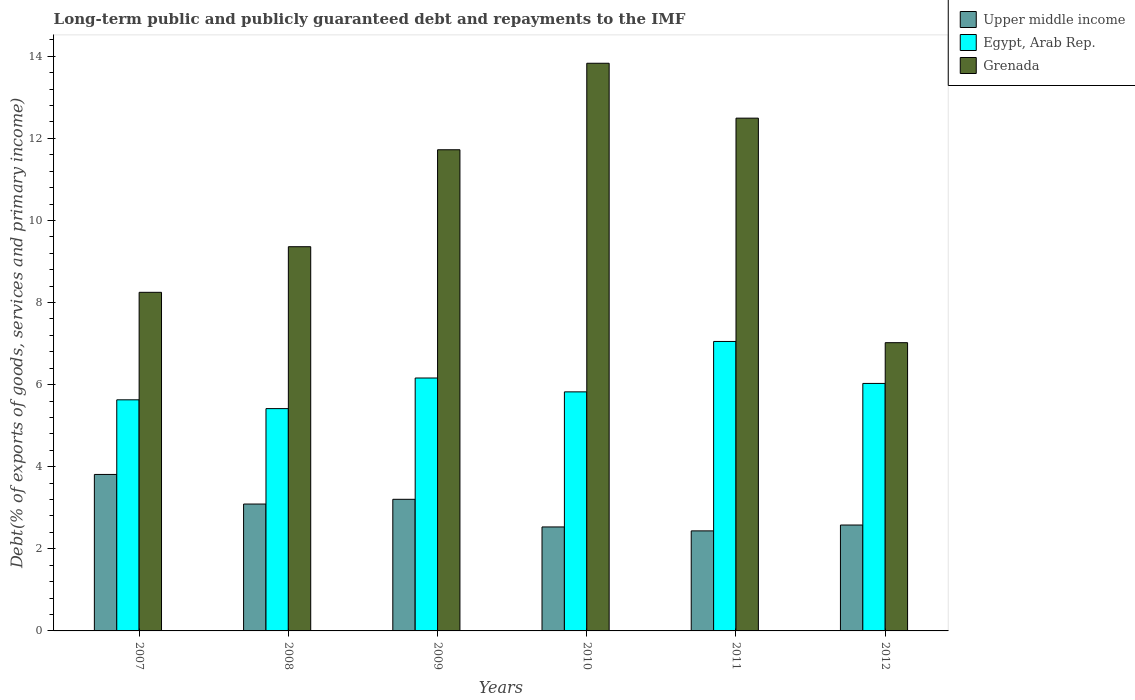How many different coloured bars are there?
Ensure brevity in your answer.  3. How many groups of bars are there?
Provide a short and direct response. 6. Are the number of bars per tick equal to the number of legend labels?
Keep it short and to the point. Yes. Are the number of bars on each tick of the X-axis equal?
Keep it short and to the point. Yes. How many bars are there on the 1st tick from the right?
Provide a succinct answer. 3. In how many cases, is the number of bars for a given year not equal to the number of legend labels?
Your response must be concise. 0. What is the debt and repayments in Egypt, Arab Rep. in 2011?
Ensure brevity in your answer.  7.05. Across all years, what is the maximum debt and repayments in Upper middle income?
Offer a terse response. 3.81. Across all years, what is the minimum debt and repayments in Grenada?
Give a very brief answer. 7.02. What is the total debt and repayments in Egypt, Arab Rep. in the graph?
Provide a short and direct response. 36.11. What is the difference between the debt and repayments in Egypt, Arab Rep. in 2009 and that in 2012?
Your answer should be compact. 0.13. What is the difference between the debt and repayments in Egypt, Arab Rep. in 2007 and the debt and repayments in Upper middle income in 2010?
Ensure brevity in your answer.  3.1. What is the average debt and repayments in Egypt, Arab Rep. per year?
Make the answer very short. 6.02. In the year 2009, what is the difference between the debt and repayments in Grenada and debt and repayments in Egypt, Arab Rep.?
Your response must be concise. 5.56. In how many years, is the debt and repayments in Upper middle income greater than 1.2000000000000002 %?
Ensure brevity in your answer.  6. What is the ratio of the debt and repayments in Grenada in 2007 to that in 2012?
Provide a succinct answer. 1.17. Is the debt and repayments in Grenada in 2010 less than that in 2011?
Offer a terse response. No. What is the difference between the highest and the second highest debt and repayments in Egypt, Arab Rep.?
Your answer should be very brief. 0.89. What is the difference between the highest and the lowest debt and repayments in Grenada?
Ensure brevity in your answer.  6.81. In how many years, is the debt and repayments in Grenada greater than the average debt and repayments in Grenada taken over all years?
Make the answer very short. 3. Is the sum of the debt and repayments in Grenada in 2007 and 2011 greater than the maximum debt and repayments in Upper middle income across all years?
Ensure brevity in your answer.  Yes. What does the 2nd bar from the left in 2009 represents?
Make the answer very short. Egypt, Arab Rep. What does the 3rd bar from the right in 2008 represents?
Make the answer very short. Upper middle income. What is the difference between two consecutive major ticks on the Y-axis?
Make the answer very short. 2. Are the values on the major ticks of Y-axis written in scientific E-notation?
Offer a very short reply. No. Does the graph contain grids?
Ensure brevity in your answer.  No. How are the legend labels stacked?
Your answer should be very brief. Vertical. What is the title of the graph?
Your answer should be very brief. Long-term public and publicly guaranteed debt and repayments to the IMF. What is the label or title of the X-axis?
Offer a very short reply. Years. What is the label or title of the Y-axis?
Your response must be concise. Debt(% of exports of goods, services and primary income). What is the Debt(% of exports of goods, services and primary income) in Upper middle income in 2007?
Your answer should be compact. 3.81. What is the Debt(% of exports of goods, services and primary income) of Egypt, Arab Rep. in 2007?
Ensure brevity in your answer.  5.63. What is the Debt(% of exports of goods, services and primary income) in Grenada in 2007?
Provide a short and direct response. 8.25. What is the Debt(% of exports of goods, services and primary income) of Upper middle income in 2008?
Make the answer very short. 3.09. What is the Debt(% of exports of goods, services and primary income) in Egypt, Arab Rep. in 2008?
Provide a short and direct response. 5.42. What is the Debt(% of exports of goods, services and primary income) of Grenada in 2008?
Make the answer very short. 9.36. What is the Debt(% of exports of goods, services and primary income) of Upper middle income in 2009?
Give a very brief answer. 3.21. What is the Debt(% of exports of goods, services and primary income) of Egypt, Arab Rep. in 2009?
Ensure brevity in your answer.  6.16. What is the Debt(% of exports of goods, services and primary income) in Grenada in 2009?
Give a very brief answer. 11.72. What is the Debt(% of exports of goods, services and primary income) of Upper middle income in 2010?
Offer a terse response. 2.53. What is the Debt(% of exports of goods, services and primary income) of Egypt, Arab Rep. in 2010?
Your answer should be very brief. 5.82. What is the Debt(% of exports of goods, services and primary income) of Grenada in 2010?
Offer a terse response. 13.83. What is the Debt(% of exports of goods, services and primary income) in Upper middle income in 2011?
Keep it short and to the point. 2.44. What is the Debt(% of exports of goods, services and primary income) of Egypt, Arab Rep. in 2011?
Keep it short and to the point. 7.05. What is the Debt(% of exports of goods, services and primary income) in Grenada in 2011?
Keep it short and to the point. 12.49. What is the Debt(% of exports of goods, services and primary income) in Upper middle income in 2012?
Offer a very short reply. 2.58. What is the Debt(% of exports of goods, services and primary income) of Egypt, Arab Rep. in 2012?
Offer a very short reply. 6.03. What is the Debt(% of exports of goods, services and primary income) of Grenada in 2012?
Your response must be concise. 7.02. Across all years, what is the maximum Debt(% of exports of goods, services and primary income) in Upper middle income?
Offer a very short reply. 3.81. Across all years, what is the maximum Debt(% of exports of goods, services and primary income) in Egypt, Arab Rep.?
Your response must be concise. 7.05. Across all years, what is the maximum Debt(% of exports of goods, services and primary income) of Grenada?
Your answer should be compact. 13.83. Across all years, what is the minimum Debt(% of exports of goods, services and primary income) of Upper middle income?
Offer a very short reply. 2.44. Across all years, what is the minimum Debt(% of exports of goods, services and primary income) of Egypt, Arab Rep.?
Offer a terse response. 5.42. Across all years, what is the minimum Debt(% of exports of goods, services and primary income) of Grenada?
Your answer should be very brief. 7.02. What is the total Debt(% of exports of goods, services and primary income) of Upper middle income in the graph?
Give a very brief answer. 17.66. What is the total Debt(% of exports of goods, services and primary income) of Egypt, Arab Rep. in the graph?
Keep it short and to the point. 36.11. What is the total Debt(% of exports of goods, services and primary income) of Grenada in the graph?
Your response must be concise. 62.67. What is the difference between the Debt(% of exports of goods, services and primary income) in Upper middle income in 2007 and that in 2008?
Offer a very short reply. 0.72. What is the difference between the Debt(% of exports of goods, services and primary income) in Egypt, Arab Rep. in 2007 and that in 2008?
Give a very brief answer. 0.21. What is the difference between the Debt(% of exports of goods, services and primary income) of Grenada in 2007 and that in 2008?
Make the answer very short. -1.11. What is the difference between the Debt(% of exports of goods, services and primary income) in Upper middle income in 2007 and that in 2009?
Offer a very short reply. 0.61. What is the difference between the Debt(% of exports of goods, services and primary income) in Egypt, Arab Rep. in 2007 and that in 2009?
Your answer should be very brief. -0.53. What is the difference between the Debt(% of exports of goods, services and primary income) in Grenada in 2007 and that in 2009?
Offer a terse response. -3.47. What is the difference between the Debt(% of exports of goods, services and primary income) in Upper middle income in 2007 and that in 2010?
Your answer should be very brief. 1.28. What is the difference between the Debt(% of exports of goods, services and primary income) of Egypt, Arab Rep. in 2007 and that in 2010?
Make the answer very short. -0.19. What is the difference between the Debt(% of exports of goods, services and primary income) of Grenada in 2007 and that in 2010?
Ensure brevity in your answer.  -5.58. What is the difference between the Debt(% of exports of goods, services and primary income) in Upper middle income in 2007 and that in 2011?
Offer a terse response. 1.37. What is the difference between the Debt(% of exports of goods, services and primary income) of Egypt, Arab Rep. in 2007 and that in 2011?
Keep it short and to the point. -1.42. What is the difference between the Debt(% of exports of goods, services and primary income) in Grenada in 2007 and that in 2011?
Provide a succinct answer. -4.24. What is the difference between the Debt(% of exports of goods, services and primary income) of Upper middle income in 2007 and that in 2012?
Provide a short and direct response. 1.23. What is the difference between the Debt(% of exports of goods, services and primary income) of Egypt, Arab Rep. in 2007 and that in 2012?
Provide a succinct answer. -0.4. What is the difference between the Debt(% of exports of goods, services and primary income) in Grenada in 2007 and that in 2012?
Make the answer very short. 1.23. What is the difference between the Debt(% of exports of goods, services and primary income) of Upper middle income in 2008 and that in 2009?
Give a very brief answer. -0.12. What is the difference between the Debt(% of exports of goods, services and primary income) of Egypt, Arab Rep. in 2008 and that in 2009?
Ensure brevity in your answer.  -0.75. What is the difference between the Debt(% of exports of goods, services and primary income) of Grenada in 2008 and that in 2009?
Make the answer very short. -2.36. What is the difference between the Debt(% of exports of goods, services and primary income) in Upper middle income in 2008 and that in 2010?
Make the answer very short. 0.56. What is the difference between the Debt(% of exports of goods, services and primary income) in Egypt, Arab Rep. in 2008 and that in 2010?
Your answer should be very brief. -0.41. What is the difference between the Debt(% of exports of goods, services and primary income) of Grenada in 2008 and that in 2010?
Ensure brevity in your answer.  -4.47. What is the difference between the Debt(% of exports of goods, services and primary income) in Upper middle income in 2008 and that in 2011?
Offer a very short reply. 0.65. What is the difference between the Debt(% of exports of goods, services and primary income) in Egypt, Arab Rep. in 2008 and that in 2011?
Ensure brevity in your answer.  -1.64. What is the difference between the Debt(% of exports of goods, services and primary income) of Grenada in 2008 and that in 2011?
Provide a succinct answer. -3.13. What is the difference between the Debt(% of exports of goods, services and primary income) in Upper middle income in 2008 and that in 2012?
Give a very brief answer. 0.51. What is the difference between the Debt(% of exports of goods, services and primary income) of Egypt, Arab Rep. in 2008 and that in 2012?
Your answer should be very brief. -0.61. What is the difference between the Debt(% of exports of goods, services and primary income) in Grenada in 2008 and that in 2012?
Your response must be concise. 2.34. What is the difference between the Debt(% of exports of goods, services and primary income) in Upper middle income in 2009 and that in 2010?
Make the answer very short. 0.67. What is the difference between the Debt(% of exports of goods, services and primary income) of Egypt, Arab Rep. in 2009 and that in 2010?
Offer a terse response. 0.34. What is the difference between the Debt(% of exports of goods, services and primary income) in Grenada in 2009 and that in 2010?
Keep it short and to the point. -2.11. What is the difference between the Debt(% of exports of goods, services and primary income) in Upper middle income in 2009 and that in 2011?
Offer a terse response. 0.77. What is the difference between the Debt(% of exports of goods, services and primary income) in Egypt, Arab Rep. in 2009 and that in 2011?
Your answer should be very brief. -0.89. What is the difference between the Debt(% of exports of goods, services and primary income) in Grenada in 2009 and that in 2011?
Ensure brevity in your answer.  -0.77. What is the difference between the Debt(% of exports of goods, services and primary income) of Upper middle income in 2009 and that in 2012?
Your answer should be very brief. 0.63. What is the difference between the Debt(% of exports of goods, services and primary income) in Egypt, Arab Rep. in 2009 and that in 2012?
Provide a succinct answer. 0.13. What is the difference between the Debt(% of exports of goods, services and primary income) of Grenada in 2009 and that in 2012?
Make the answer very short. 4.7. What is the difference between the Debt(% of exports of goods, services and primary income) of Upper middle income in 2010 and that in 2011?
Provide a succinct answer. 0.1. What is the difference between the Debt(% of exports of goods, services and primary income) in Egypt, Arab Rep. in 2010 and that in 2011?
Give a very brief answer. -1.23. What is the difference between the Debt(% of exports of goods, services and primary income) of Grenada in 2010 and that in 2011?
Offer a terse response. 1.34. What is the difference between the Debt(% of exports of goods, services and primary income) of Upper middle income in 2010 and that in 2012?
Give a very brief answer. -0.05. What is the difference between the Debt(% of exports of goods, services and primary income) of Egypt, Arab Rep. in 2010 and that in 2012?
Offer a terse response. -0.21. What is the difference between the Debt(% of exports of goods, services and primary income) of Grenada in 2010 and that in 2012?
Your answer should be compact. 6.81. What is the difference between the Debt(% of exports of goods, services and primary income) of Upper middle income in 2011 and that in 2012?
Keep it short and to the point. -0.14. What is the difference between the Debt(% of exports of goods, services and primary income) of Egypt, Arab Rep. in 2011 and that in 2012?
Offer a very short reply. 1.02. What is the difference between the Debt(% of exports of goods, services and primary income) in Grenada in 2011 and that in 2012?
Ensure brevity in your answer.  5.47. What is the difference between the Debt(% of exports of goods, services and primary income) of Upper middle income in 2007 and the Debt(% of exports of goods, services and primary income) of Egypt, Arab Rep. in 2008?
Give a very brief answer. -1.6. What is the difference between the Debt(% of exports of goods, services and primary income) of Upper middle income in 2007 and the Debt(% of exports of goods, services and primary income) of Grenada in 2008?
Make the answer very short. -5.55. What is the difference between the Debt(% of exports of goods, services and primary income) in Egypt, Arab Rep. in 2007 and the Debt(% of exports of goods, services and primary income) in Grenada in 2008?
Your answer should be very brief. -3.73. What is the difference between the Debt(% of exports of goods, services and primary income) in Upper middle income in 2007 and the Debt(% of exports of goods, services and primary income) in Egypt, Arab Rep. in 2009?
Keep it short and to the point. -2.35. What is the difference between the Debt(% of exports of goods, services and primary income) in Upper middle income in 2007 and the Debt(% of exports of goods, services and primary income) in Grenada in 2009?
Provide a succinct answer. -7.91. What is the difference between the Debt(% of exports of goods, services and primary income) of Egypt, Arab Rep. in 2007 and the Debt(% of exports of goods, services and primary income) of Grenada in 2009?
Give a very brief answer. -6.09. What is the difference between the Debt(% of exports of goods, services and primary income) in Upper middle income in 2007 and the Debt(% of exports of goods, services and primary income) in Egypt, Arab Rep. in 2010?
Offer a terse response. -2.01. What is the difference between the Debt(% of exports of goods, services and primary income) in Upper middle income in 2007 and the Debt(% of exports of goods, services and primary income) in Grenada in 2010?
Give a very brief answer. -10.02. What is the difference between the Debt(% of exports of goods, services and primary income) in Egypt, Arab Rep. in 2007 and the Debt(% of exports of goods, services and primary income) in Grenada in 2010?
Your response must be concise. -8.2. What is the difference between the Debt(% of exports of goods, services and primary income) in Upper middle income in 2007 and the Debt(% of exports of goods, services and primary income) in Egypt, Arab Rep. in 2011?
Provide a short and direct response. -3.24. What is the difference between the Debt(% of exports of goods, services and primary income) in Upper middle income in 2007 and the Debt(% of exports of goods, services and primary income) in Grenada in 2011?
Your answer should be compact. -8.68. What is the difference between the Debt(% of exports of goods, services and primary income) of Egypt, Arab Rep. in 2007 and the Debt(% of exports of goods, services and primary income) of Grenada in 2011?
Make the answer very short. -6.86. What is the difference between the Debt(% of exports of goods, services and primary income) in Upper middle income in 2007 and the Debt(% of exports of goods, services and primary income) in Egypt, Arab Rep. in 2012?
Your response must be concise. -2.22. What is the difference between the Debt(% of exports of goods, services and primary income) of Upper middle income in 2007 and the Debt(% of exports of goods, services and primary income) of Grenada in 2012?
Offer a terse response. -3.21. What is the difference between the Debt(% of exports of goods, services and primary income) in Egypt, Arab Rep. in 2007 and the Debt(% of exports of goods, services and primary income) in Grenada in 2012?
Give a very brief answer. -1.39. What is the difference between the Debt(% of exports of goods, services and primary income) of Upper middle income in 2008 and the Debt(% of exports of goods, services and primary income) of Egypt, Arab Rep. in 2009?
Keep it short and to the point. -3.07. What is the difference between the Debt(% of exports of goods, services and primary income) in Upper middle income in 2008 and the Debt(% of exports of goods, services and primary income) in Grenada in 2009?
Your answer should be very brief. -8.63. What is the difference between the Debt(% of exports of goods, services and primary income) in Egypt, Arab Rep. in 2008 and the Debt(% of exports of goods, services and primary income) in Grenada in 2009?
Ensure brevity in your answer.  -6.31. What is the difference between the Debt(% of exports of goods, services and primary income) in Upper middle income in 2008 and the Debt(% of exports of goods, services and primary income) in Egypt, Arab Rep. in 2010?
Provide a succinct answer. -2.73. What is the difference between the Debt(% of exports of goods, services and primary income) of Upper middle income in 2008 and the Debt(% of exports of goods, services and primary income) of Grenada in 2010?
Provide a succinct answer. -10.74. What is the difference between the Debt(% of exports of goods, services and primary income) of Egypt, Arab Rep. in 2008 and the Debt(% of exports of goods, services and primary income) of Grenada in 2010?
Keep it short and to the point. -8.41. What is the difference between the Debt(% of exports of goods, services and primary income) in Upper middle income in 2008 and the Debt(% of exports of goods, services and primary income) in Egypt, Arab Rep. in 2011?
Give a very brief answer. -3.96. What is the difference between the Debt(% of exports of goods, services and primary income) in Upper middle income in 2008 and the Debt(% of exports of goods, services and primary income) in Grenada in 2011?
Offer a terse response. -9.4. What is the difference between the Debt(% of exports of goods, services and primary income) of Egypt, Arab Rep. in 2008 and the Debt(% of exports of goods, services and primary income) of Grenada in 2011?
Offer a terse response. -7.08. What is the difference between the Debt(% of exports of goods, services and primary income) in Upper middle income in 2008 and the Debt(% of exports of goods, services and primary income) in Egypt, Arab Rep. in 2012?
Keep it short and to the point. -2.94. What is the difference between the Debt(% of exports of goods, services and primary income) of Upper middle income in 2008 and the Debt(% of exports of goods, services and primary income) of Grenada in 2012?
Your answer should be very brief. -3.93. What is the difference between the Debt(% of exports of goods, services and primary income) of Egypt, Arab Rep. in 2008 and the Debt(% of exports of goods, services and primary income) of Grenada in 2012?
Keep it short and to the point. -1.61. What is the difference between the Debt(% of exports of goods, services and primary income) of Upper middle income in 2009 and the Debt(% of exports of goods, services and primary income) of Egypt, Arab Rep. in 2010?
Your response must be concise. -2.62. What is the difference between the Debt(% of exports of goods, services and primary income) of Upper middle income in 2009 and the Debt(% of exports of goods, services and primary income) of Grenada in 2010?
Ensure brevity in your answer.  -10.62. What is the difference between the Debt(% of exports of goods, services and primary income) in Egypt, Arab Rep. in 2009 and the Debt(% of exports of goods, services and primary income) in Grenada in 2010?
Your answer should be very brief. -7.67. What is the difference between the Debt(% of exports of goods, services and primary income) in Upper middle income in 2009 and the Debt(% of exports of goods, services and primary income) in Egypt, Arab Rep. in 2011?
Ensure brevity in your answer.  -3.85. What is the difference between the Debt(% of exports of goods, services and primary income) of Upper middle income in 2009 and the Debt(% of exports of goods, services and primary income) of Grenada in 2011?
Ensure brevity in your answer.  -9.29. What is the difference between the Debt(% of exports of goods, services and primary income) of Egypt, Arab Rep. in 2009 and the Debt(% of exports of goods, services and primary income) of Grenada in 2011?
Offer a terse response. -6.33. What is the difference between the Debt(% of exports of goods, services and primary income) of Upper middle income in 2009 and the Debt(% of exports of goods, services and primary income) of Egypt, Arab Rep. in 2012?
Make the answer very short. -2.82. What is the difference between the Debt(% of exports of goods, services and primary income) of Upper middle income in 2009 and the Debt(% of exports of goods, services and primary income) of Grenada in 2012?
Provide a short and direct response. -3.82. What is the difference between the Debt(% of exports of goods, services and primary income) in Egypt, Arab Rep. in 2009 and the Debt(% of exports of goods, services and primary income) in Grenada in 2012?
Your answer should be very brief. -0.86. What is the difference between the Debt(% of exports of goods, services and primary income) of Upper middle income in 2010 and the Debt(% of exports of goods, services and primary income) of Egypt, Arab Rep. in 2011?
Make the answer very short. -4.52. What is the difference between the Debt(% of exports of goods, services and primary income) in Upper middle income in 2010 and the Debt(% of exports of goods, services and primary income) in Grenada in 2011?
Keep it short and to the point. -9.96. What is the difference between the Debt(% of exports of goods, services and primary income) of Egypt, Arab Rep. in 2010 and the Debt(% of exports of goods, services and primary income) of Grenada in 2011?
Your answer should be very brief. -6.67. What is the difference between the Debt(% of exports of goods, services and primary income) of Upper middle income in 2010 and the Debt(% of exports of goods, services and primary income) of Egypt, Arab Rep. in 2012?
Your response must be concise. -3.5. What is the difference between the Debt(% of exports of goods, services and primary income) of Upper middle income in 2010 and the Debt(% of exports of goods, services and primary income) of Grenada in 2012?
Provide a short and direct response. -4.49. What is the difference between the Debt(% of exports of goods, services and primary income) of Egypt, Arab Rep. in 2010 and the Debt(% of exports of goods, services and primary income) of Grenada in 2012?
Your answer should be compact. -1.2. What is the difference between the Debt(% of exports of goods, services and primary income) of Upper middle income in 2011 and the Debt(% of exports of goods, services and primary income) of Egypt, Arab Rep. in 2012?
Your response must be concise. -3.59. What is the difference between the Debt(% of exports of goods, services and primary income) of Upper middle income in 2011 and the Debt(% of exports of goods, services and primary income) of Grenada in 2012?
Your response must be concise. -4.58. What is the difference between the Debt(% of exports of goods, services and primary income) of Egypt, Arab Rep. in 2011 and the Debt(% of exports of goods, services and primary income) of Grenada in 2012?
Offer a very short reply. 0.03. What is the average Debt(% of exports of goods, services and primary income) of Upper middle income per year?
Ensure brevity in your answer.  2.94. What is the average Debt(% of exports of goods, services and primary income) of Egypt, Arab Rep. per year?
Provide a short and direct response. 6.02. What is the average Debt(% of exports of goods, services and primary income) in Grenada per year?
Offer a very short reply. 10.45. In the year 2007, what is the difference between the Debt(% of exports of goods, services and primary income) of Upper middle income and Debt(% of exports of goods, services and primary income) of Egypt, Arab Rep.?
Ensure brevity in your answer.  -1.82. In the year 2007, what is the difference between the Debt(% of exports of goods, services and primary income) of Upper middle income and Debt(% of exports of goods, services and primary income) of Grenada?
Offer a terse response. -4.44. In the year 2007, what is the difference between the Debt(% of exports of goods, services and primary income) in Egypt, Arab Rep. and Debt(% of exports of goods, services and primary income) in Grenada?
Offer a very short reply. -2.62. In the year 2008, what is the difference between the Debt(% of exports of goods, services and primary income) of Upper middle income and Debt(% of exports of goods, services and primary income) of Egypt, Arab Rep.?
Your answer should be compact. -2.33. In the year 2008, what is the difference between the Debt(% of exports of goods, services and primary income) in Upper middle income and Debt(% of exports of goods, services and primary income) in Grenada?
Your answer should be compact. -6.27. In the year 2008, what is the difference between the Debt(% of exports of goods, services and primary income) of Egypt, Arab Rep. and Debt(% of exports of goods, services and primary income) of Grenada?
Offer a terse response. -3.94. In the year 2009, what is the difference between the Debt(% of exports of goods, services and primary income) of Upper middle income and Debt(% of exports of goods, services and primary income) of Egypt, Arab Rep.?
Make the answer very short. -2.96. In the year 2009, what is the difference between the Debt(% of exports of goods, services and primary income) of Upper middle income and Debt(% of exports of goods, services and primary income) of Grenada?
Give a very brief answer. -8.52. In the year 2009, what is the difference between the Debt(% of exports of goods, services and primary income) of Egypt, Arab Rep. and Debt(% of exports of goods, services and primary income) of Grenada?
Provide a succinct answer. -5.56. In the year 2010, what is the difference between the Debt(% of exports of goods, services and primary income) of Upper middle income and Debt(% of exports of goods, services and primary income) of Egypt, Arab Rep.?
Make the answer very short. -3.29. In the year 2010, what is the difference between the Debt(% of exports of goods, services and primary income) of Upper middle income and Debt(% of exports of goods, services and primary income) of Grenada?
Give a very brief answer. -11.3. In the year 2010, what is the difference between the Debt(% of exports of goods, services and primary income) of Egypt, Arab Rep. and Debt(% of exports of goods, services and primary income) of Grenada?
Your answer should be very brief. -8.01. In the year 2011, what is the difference between the Debt(% of exports of goods, services and primary income) of Upper middle income and Debt(% of exports of goods, services and primary income) of Egypt, Arab Rep.?
Offer a very short reply. -4.61. In the year 2011, what is the difference between the Debt(% of exports of goods, services and primary income) in Upper middle income and Debt(% of exports of goods, services and primary income) in Grenada?
Ensure brevity in your answer.  -10.05. In the year 2011, what is the difference between the Debt(% of exports of goods, services and primary income) in Egypt, Arab Rep. and Debt(% of exports of goods, services and primary income) in Grenada?
Offer a terse response. -5.44. In the year 2012, what is the difference between the Debt(% of exports of goods, services and primary income) in Upper middle income and Debt(% of exports of goods, services and primary income) in Egypt, Arab Rep.?
Give a very brief answer. -3.45. In the year 2012, what is the difference between the Debt(% of exports of goods, services and primary income) in Upper middle income and Debt(% of exports of goods, services and primary income) in Grenada?
Provide a short and direct response. -4.44. In the year 2012, what is the difference between the Debt(% of exports of goods, services and primary income) in Egypt, Arab Rep. and Debt(% of exports of goods, services and primary income) in Grenada?
Offer a very short reply. -0.99. What is the ratio of the Debt(% of exports of goods, services and primary income) in Upper middle income in 2007 to that in 2008?
Keep it short and to the point. 1.23. What is the ratio of the Debt(% of exports of goods, services and primary income) in Egypt, Arab Rep. in 2007 to that in 2008?
Give a very brief answer. 1.04. What is the ratio of the Debt(% of exports of goods, services and primary income) in Grenada in 2007 to that in 2008?
Your answer should be very brief. 0.88. What is the ratio of the Debt(% of exports of goods, services and primary income) in Upper middle income in 2007 to that in 2009?
Your answer should be compact. 1.19. What is the ratio of the Debt(% of exports of goods, services and primary income) of Egypt, Arab Rep. in 2007 to that in 2009?
Provide a short and direct response. 0.91. What is the ratio of the Debt(% of exports of goods, services and primary income) of Grenada in 2007 to that in 2009?
Keep it short and to the point. 0.7. What is the ratio of the Debt(% of exports of goods, services and primary income) in Upper middle income in 2007 to that in 2010?
Make the answer very short. 1.5. What is the ratio of the Debt(% of exports of goods, services and primary income) in Egypt, Arab Rep. in 2007 to that in 2010?
Your answer should be very brief. 0.97. What is the ratio of the Debt(% of exports of goods, services and primary income) in Grenada in 2007 to that in 2010?
Your answer should be very brief. 0.6. What is the ratio of the Debt(% of exports of goods, services and primary income) of Upper middle income in 2007 to that in 2011?
Keep it short and to the point. 1.56. What is the ratio of the Debt(% of exports of goods, services and primary income) in Egypt, Arab Rep. in 2007 to that in 2011?
Give a very brief answer. 0.8. What is the ratio of the Debt(% of exports of goods, services and primary income) in Grenada in 2007 to that in 2011?
Make the answer very short. 0.66. What is the ratio of the Debt(% of exports of goods, services and primary income) of Upper middle income in 2007 to that in 2012?
Your response must be concise. 1.48. What is the ratio of the Debt(% of exports of goods, services and primary income) in Egypt, Arab Rep. in 2007 to that in 2012?
Keep it short and to the point. 0.93. What is the ratio of the Debt(% of exports of goods, services and primary income) in Grenada in 2007 to that in 2012?
Keep it short and to the point. 1.17. What is the ratio of the Debt(% of exports of goods, services and primary income) in Upper middle income in 2008 to that in 2009?
Offer a very short reply. 0.96. What is the ratio of the Debt(% of exports of goods, services and primary income) in Egypt, Arab Rep. in 2008 to that in 2009?
Provide a short and direct response. 0.88. What is the ratio of the Debt(% of exports of goods, services and primary income) of Grenada in 2008 to that in 2009?
Offer a very short reply. 0.8. What is the ratio of the Debt(% of exports of goods, services and primary income) of Upper middle income in 2008 to that in 2010?
Give a very brief answer. 1.22. What is the ratio of the Debt(% of exports of goods, services and primary income) of Egypt, Arab Rep. in 2008 to that in 2010?
Keep it short and to the point. 0.93. What is the ratio of the Debt(% of exports of goods, services and primary income) of Grenada in 2008 to that in 2010?
Give a very brief answer. 0.68. What is the ratio of the Debt(% of exports of goods, services and primary income) in Upper middle income in 2008 to that in 2011?
Offer a very short reply. 1.27. What is the ratio of the Debt(% of exports of goods, services and primary income) in Egypt, Arab Rep. in 2008 to that in 2011?
Your answer should be compact. 0.77. What is the ratio of the Debt(% of exports of goods, services and primary income) in Grenada in 2008 to that in 2011?
Give a very brief answer. 0.75. What is the ratio of the Debt(% of exports of goods, services and primary income) in Upper middle income in 2008 to that in 2012?
Offer a very short reply. 1.2. What is the ratio of the Debt(% of exports of goods, services and primary income) of Egypt, Arab Rep. in 2008 to that in 2012?
Ensure brevity in your answer.  0.9. What is the ratio of the Debt(% of exports of goods, services and primary income) of Grenada in 2008 to that in 2012?
Offer a terse response. 1.33. What is the ratio of the Debt(% of exports of goods, services and primary income) in Upper middle income in 2009 to that in 2010?
Ensure brevity in your answer.  1.27. What is the ratio of the Debt(% of exports of goods, services and primary income) of Egypt, Arab Rep. in 2009 to that in 2010?
Keep it short and to the point. 1.06. What is the ratio of the Debt(% of exports of goods, services and primary income) in Grenada in 2009 to that in 2010?
Your answer should be very brief. 0.85. What is the ratio of the Debt(% of exports of goods, services and primary income) of Upper middle income in 2009 to that in 2011?
Your answer should be compact. 1.32. What is the ratio of the Debt(% of exports of goods, services and primary income) of Egypt, Arab Rep. in 2009 to that in 2011?
Provide a succinct answer. 0.87. What is the ratio of the Debt(% of exports of goods, services and primary income) in Grenada in 2009 to that in 2011?
Give a very brief answer. 0.94. What is the ratio of the Debt(% of exports of goods, services and primary income) of Upper middle income in 2009 to that in 2012?
Provide a succinct answer. 1.24. What is the ratio of the Debt(% of exports of goods, services and primary income) in Egypt, Arab Rep. in 2009 to that in 2012?
Provide a succinct answer. 1.02. What is the ratio of the Debt(% of exports of goods, services and primary income) in Grenada in 2009 to that in 2012?
Provide a short and direct response. 1.67. What is the ratio of the Debt(% of exports of goods, services and primary income) of Upper middle income in 2010 to that in 2011?
Give a very brief answer. 1.04. What is the ratio of the Debt(% of exports of goods, services and primary income) of Egypt, Arab Rep. in 2010 to that in 2011?
Offer a terse response. 0.83. What is the ratio of the Debt(% of exports of goods, services and primary income) of Grenada in 2010 to that in 2011?
Your answer should be compact. 1.11. What is the ratio of the Debt(% of exports of goods, services and primary income) in Upper middle income in 2010 to that in 2012?
Offer a terse response. 0.98. What is the ratio of the Debt(% of exports of goods, services and primary income) in Egypt, Arab Rep. in 2010 to that in 2012?
Make the answer very short. 0.97. What is the ratio of the Debt(% of exports of goods, services and primary income) in Grenada in 2010 to that in 2012?
Your answer should be very brief. 1.97. What is the ratio of the Debt(% of exports of goods, services and primary income) of Upper middle income in 2011 to that in 2012?
Provide a short and direct response. 0.94. What is the ratio of the Debt(% of exports of goods, services and primary income) of Egypt, Arab Rep. in 2011 to that in 2012?
Give a very brief answer. 1.17. What is the ratio of the Debt(% of exports of goods, services and primary income) in Grenada in 2011 to that in 2012?
Your response must be concise. 1.78. What is the difference between the highest and the second highest Debt(% of exports of goods, services and primary income) in Upper middle income?
Provide a succinct answer. 0.61. What is the difference between the highest and the second highest Debt(% of exports of goods, services and primary income) in Egypt, Arab Rep.?
Your answer should be compact. 0.89. What is the difference between the highest and the second highest Debt(% of exports of goods, services and primary income) of Grenada?
Offer a very short reply. 1.34. What is the difference between the highest and the lowest Debt(% of exports of goods, services and primary income) of Upper middle income?
Provide a succinct answer. 1.37. What is the difference between the highest and the lowest Debt(% of exports of goods, services and primary income) of Egypt, Arab Rep.?
Keep it short and to the point. 1.64. What is the difference between the highest and the lowest Debt(% of exports of goods, services and primary income) in Grenada?
Your response must be concise. 6.81. 